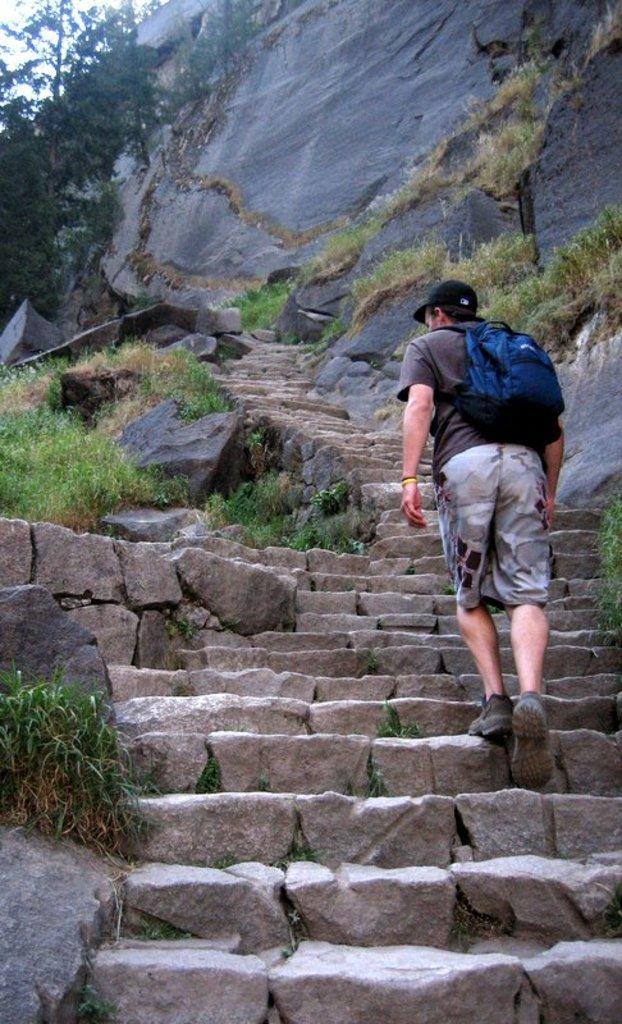Could you give a brief overview of what you see in this image? In this image in the center there is one person who is walking on stairs, and on the top of the image there are some mountains and trees and some plants. 